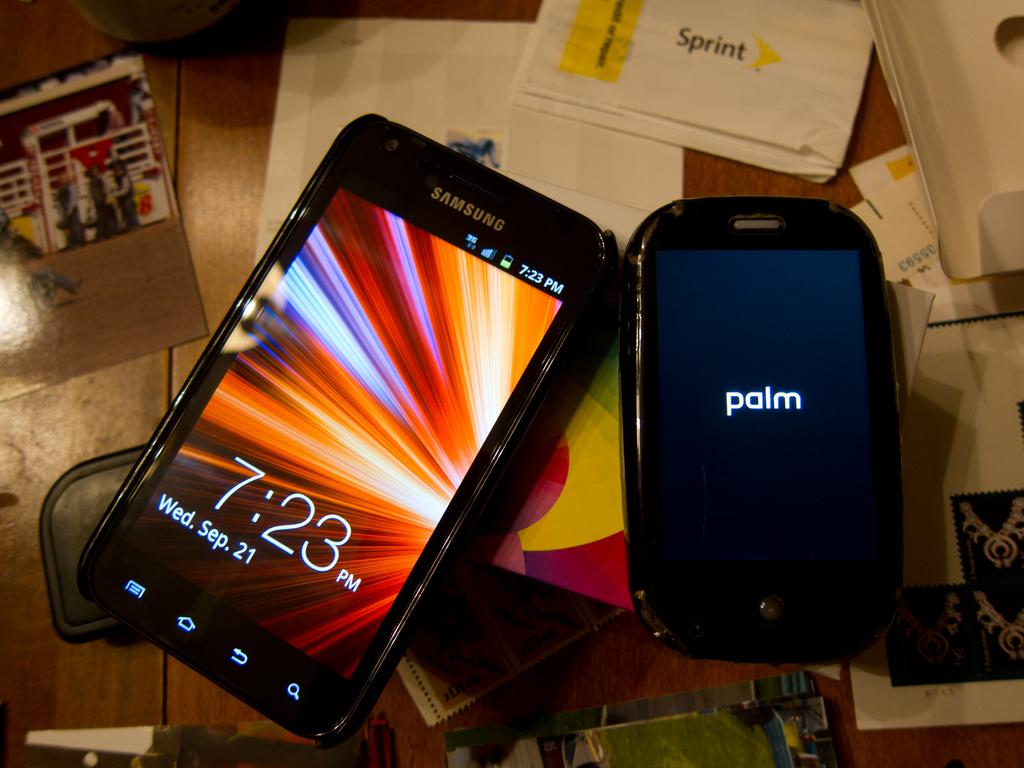<image>
Provide a brief description of the given image. A Samsung cellphone sitting next to a smaller Palm cellphone. 